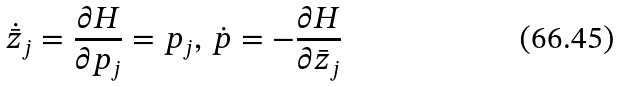<formula> <loc_0><loc_0><loc_500><loc_500>\dot { \bar { z } } _ { j } = \frac { \partial H } { \partial p _ { j } } = p _ { j } , \, \dot { p } = - \frac { \partial H } { \partial { \bar { z } } _ { j } }</formula> 